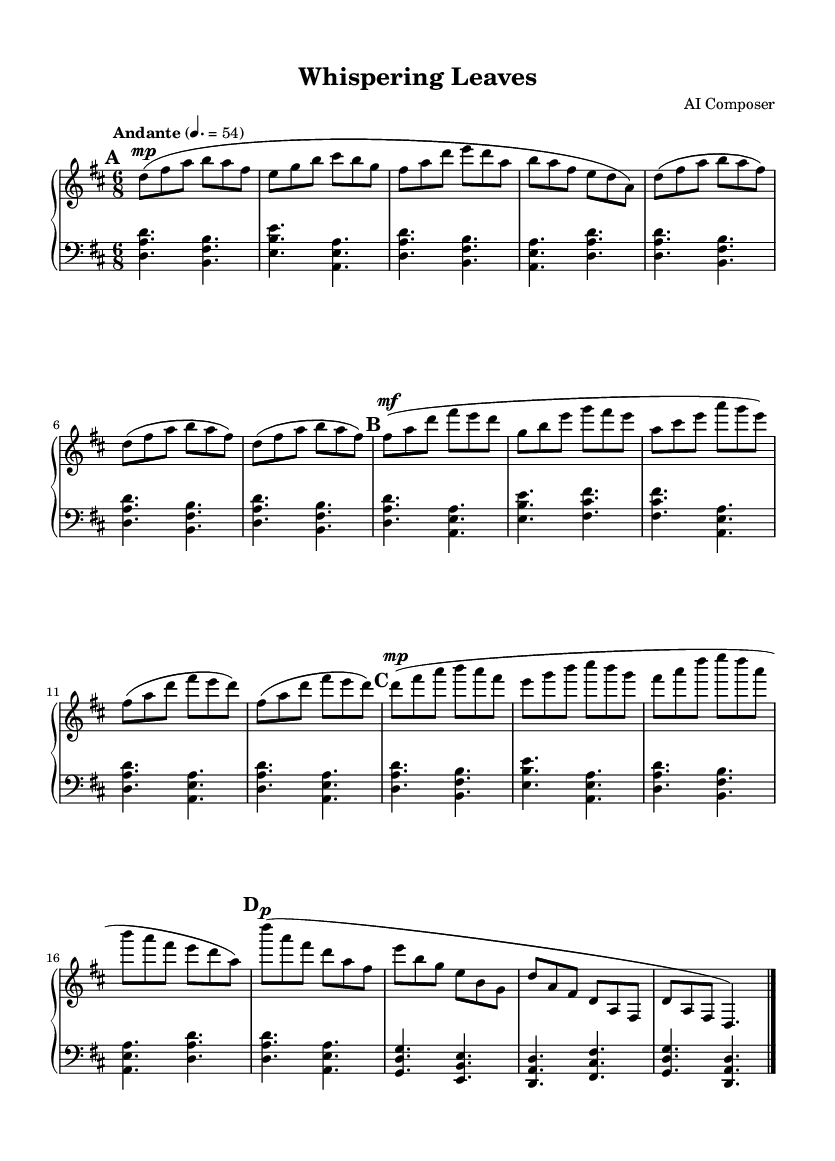What is the key signature of this music? The key signature is specified as D major, which has two sharps (F# and C#). This can be identified at the beginning of the score, where the sharps are indicated.
Answer: D major What is the time signature of the piece? The time signature is 6/8, which can be found at the start of the score, indicating that there are six eighth notes in each measure.
Answer: 6/8 What is the tempo marking for the piece? The tempo marking indicates "Andante" and a metronome marking of 54 for quarter notes, which is provided in the header section of the score. 'Andante' refers to a moderately slow tempo.
Answer: Andante, 54 How many sections are in the composition? The composition has three distinct sections: Section A, Section B, and Section A'. The sections can be identified by their labels in the score and the varying musical material.
Answer: Three What dynamic marking is used at the beginning of Section A? The dynamic marking at the beginning of Section A is marked as 'mp,' which stands for 'mezzo piano' indicating a moderately soft volume. This can be seen in the upper staff at the start of Section A.
Answer: mp In which section does the music return to the original theme? The music returns to the original theme in Section A', which is a shortened version of Section A. This can be identified by the 'Section A' label and the similarity in melodic material.
Answer: Section A' How many times is Section B repeated? Section B is repeated two times as indicated by the repeat sign following the measures of that section. The repeat sign indicates that the measure should be played again.
Answer: Two times 